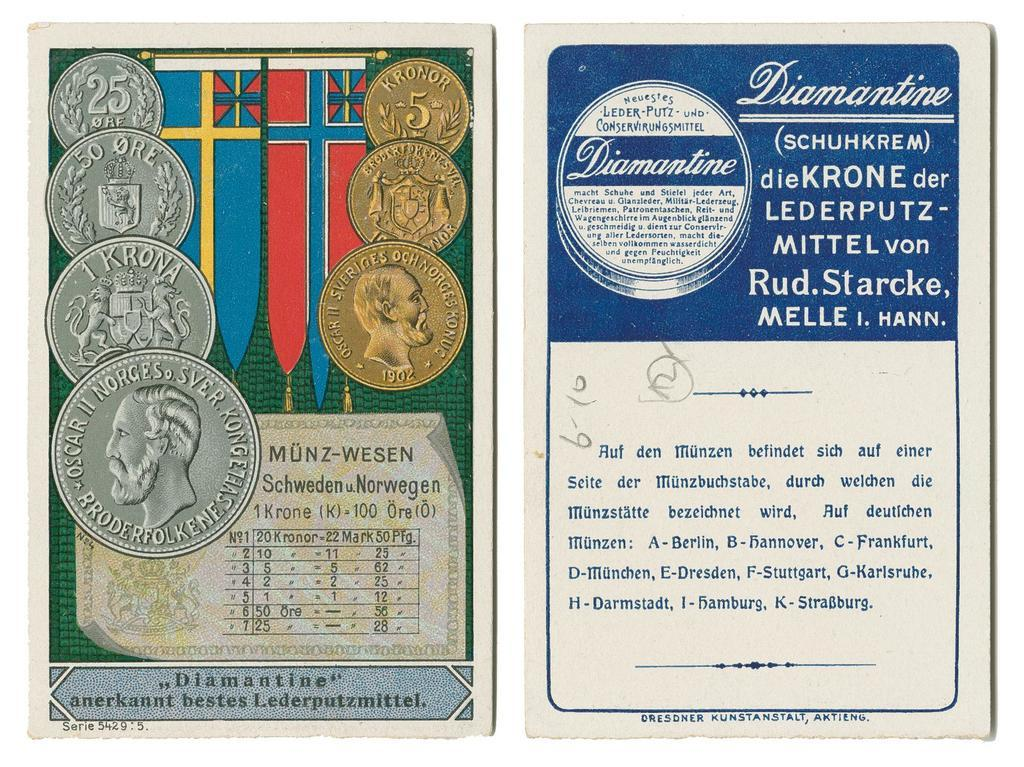<image>
Give a short and clear explanation of the subsequent image. Two cards side by side with one saying "Diamantine" on the top. 